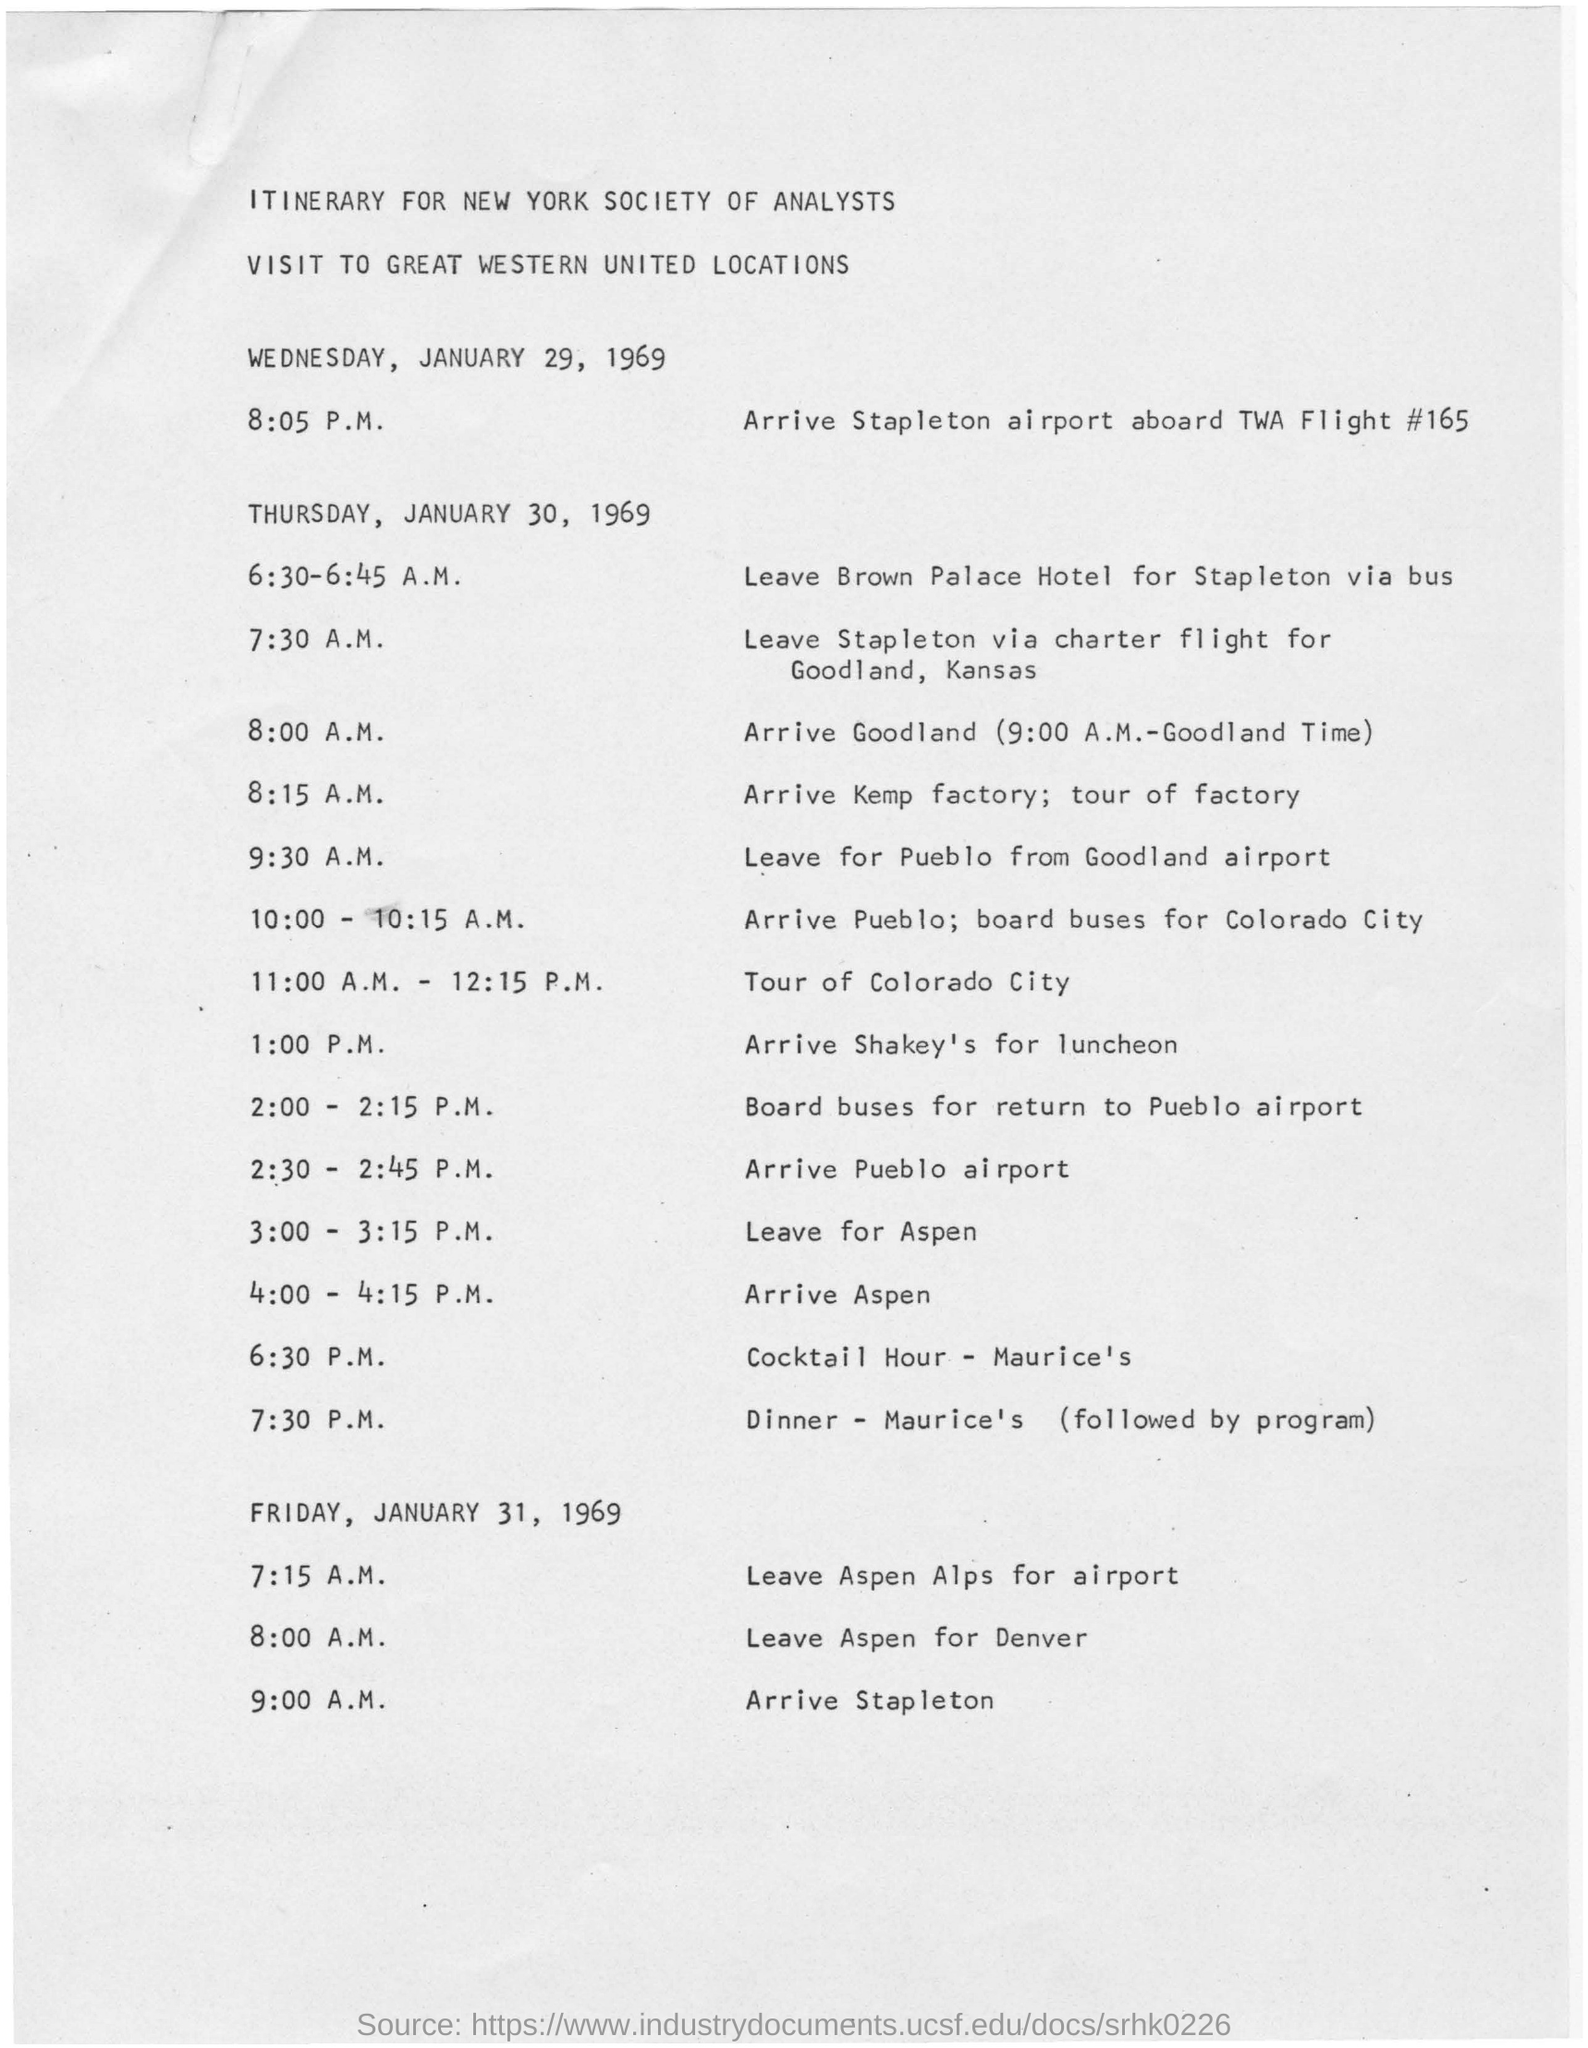Who is this itinerary in the document for?
Your answer should be compact. NEW YORK SOCIETY OF ANALYSTS. What is the flight number mentioned for the flight to Stapleton?
Make the answer very short. TWA flight #165. What is the itinerary for?
Your response must be concise. VISIT TO GREAT WESTERN UNITED LOCATIONS. What date does the visit start?
Provide a succinct answer. WEDNESDAY, JANUARY 29, 1969. What date does the visit end?
Make the answer very short. Friday, January 31, 1969. 